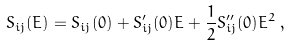Convert formula to latex. <formula><loc_0><loc_0><loc_500><loc_500>S _ { i j } ( E ) = S _ { i j } ( 0 ) + S _ { i j } ^ { \prime } ( 0 ) E + \frac { 1 } { 2 } S _ { i j } ^ { \prime \prime } ( 0 ) E ^ { 2 } \, ,</formula> 